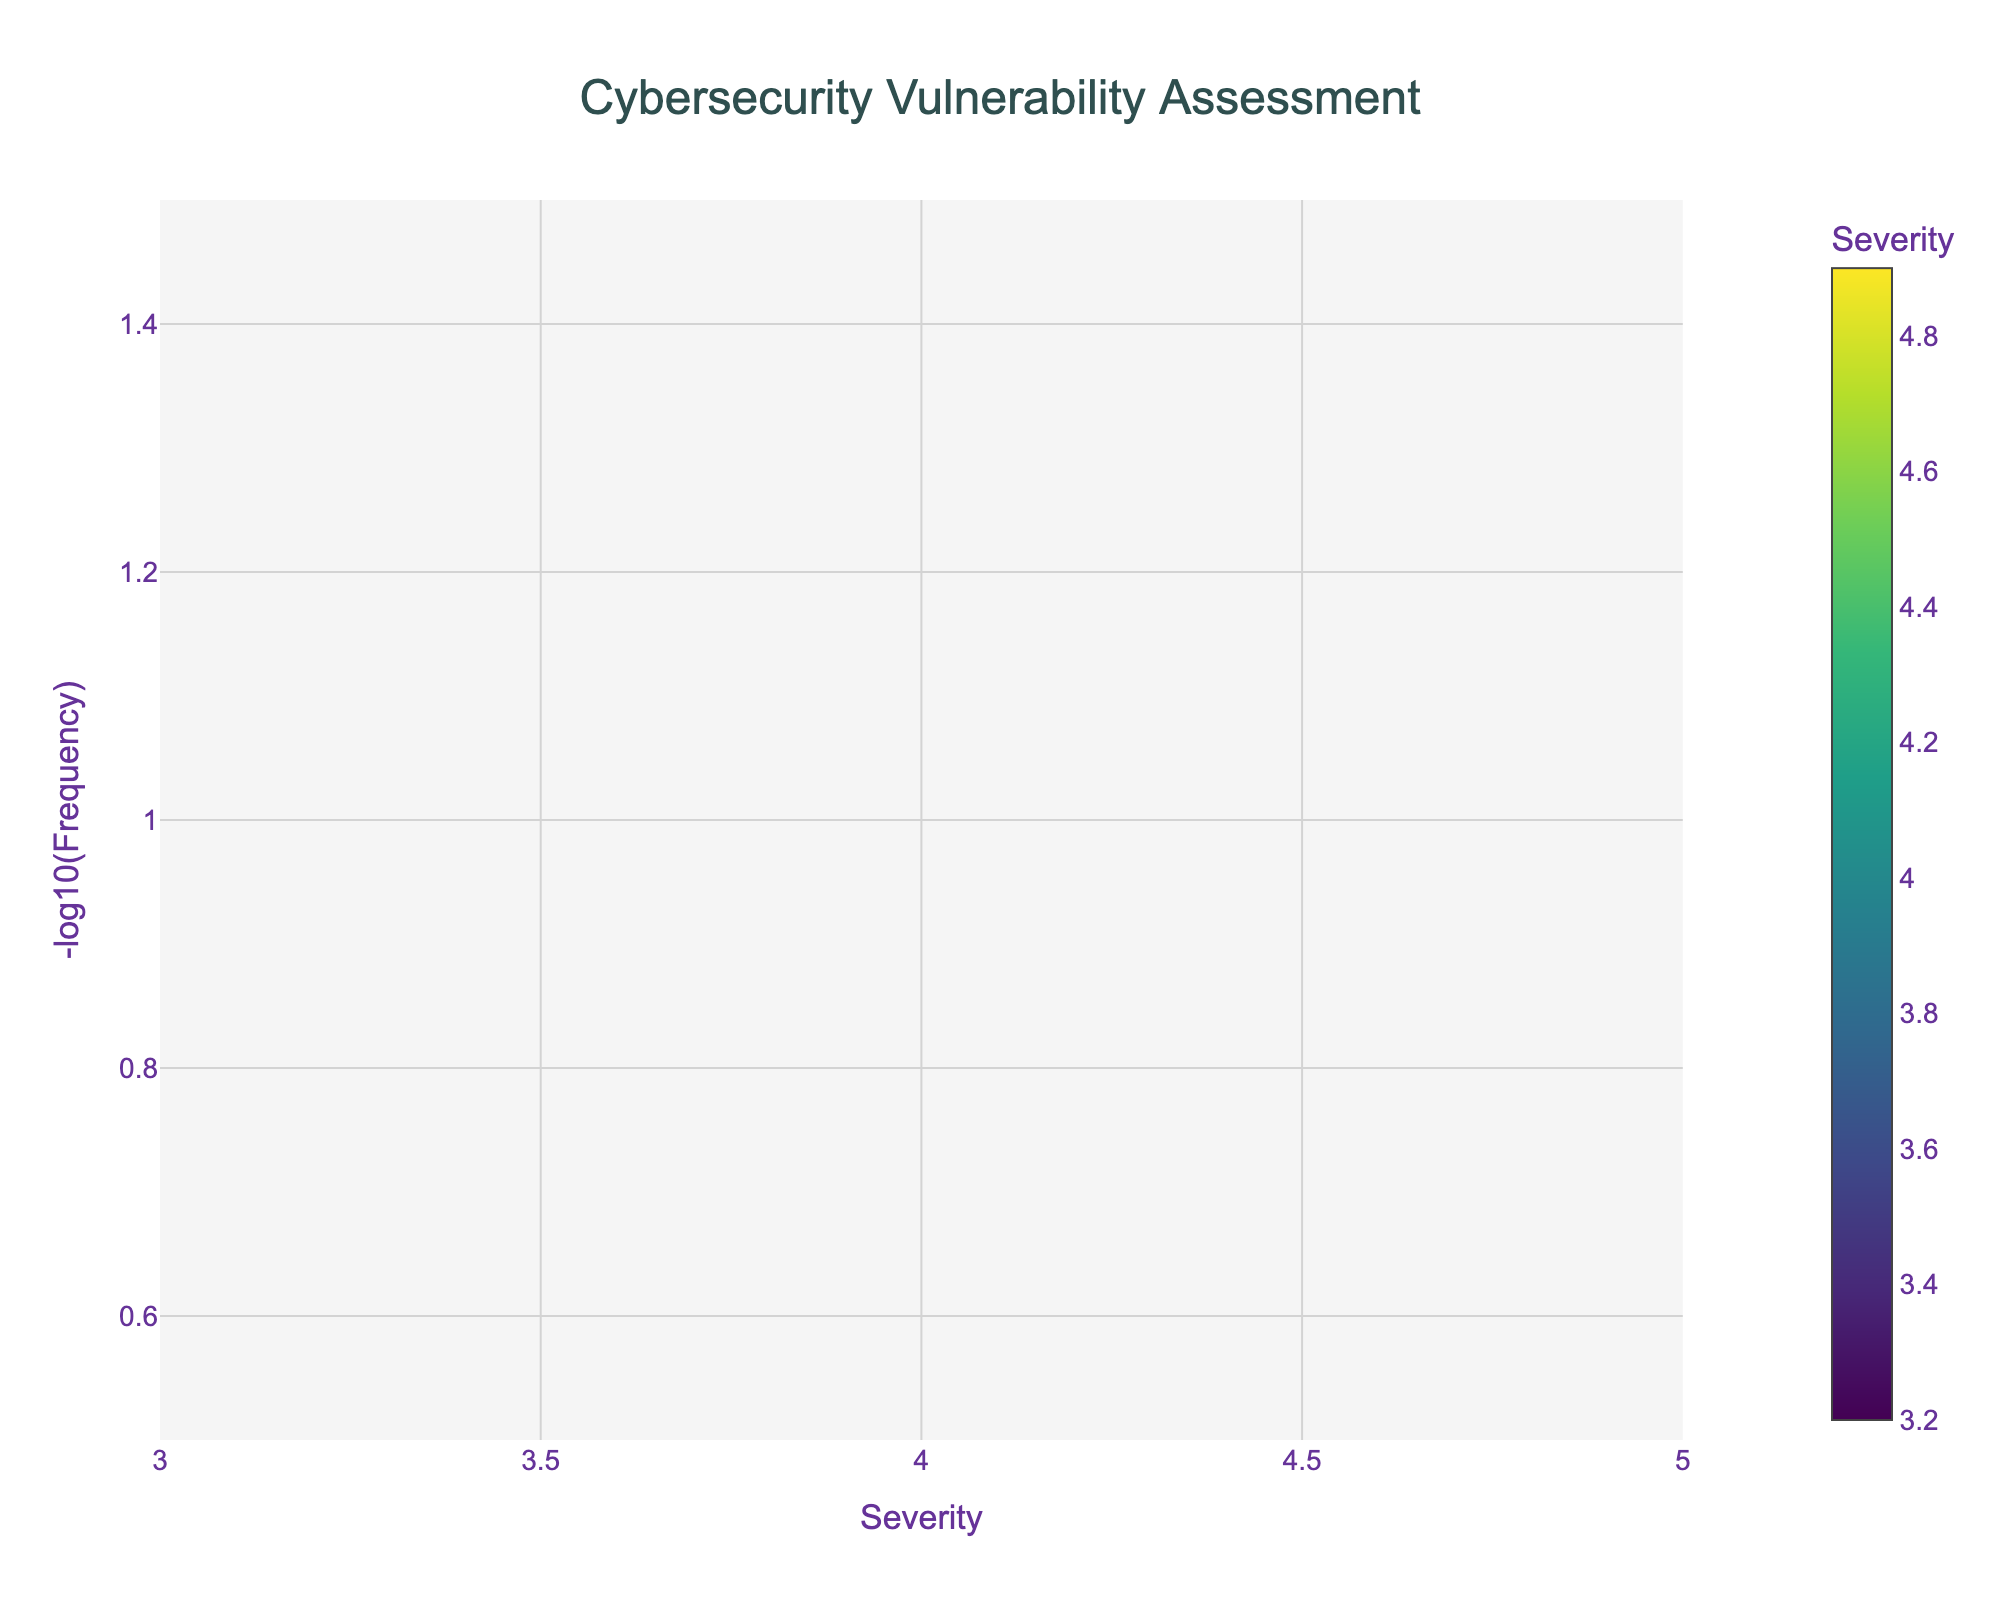What's the title of the figure? The title is usually located at the top of the figure. Here, the title is displayed centrally and given in large, bold font.
Answer: Cybersecurity Vulnerability Assessment How many unique vulnerabilities were assessed in the figure? Each dot in the volcano plot represents a unique vulnerability, and their names are visible next to the dots. By counting the dots, we can see there are 15 unique vulnerabilities.
Answer: 15 Which vulnerability has the highest severity? To find the highest severity, look for the dot that is farthest to the right on the x-axis (severity axis). The hover text for Privilege Escalation shows a severity of 4.9, the highest on the plot.
Answer: Privilege Escalation What is the frequency of the "SQL Injection" vulnerability? The frequency can be derived from the hover text associated with the dot labeled as "SQL Injection". The hover text specifies a frequency of 12.
Answer: 12 Which vulnerability occurs the most frequently? To find the most frequent vulnerability, look for the smallest value on the y-axis because the y-axis is -log10(Frequency). Information Disclosure has the smallest y-value and the highest y-position, indicating the most frequency at 25 incidents.
Answer: Information Disclosure Which vulnerabilities have a severity greater than 4.0 and a frequency lower than 10? To answer this, identify dots on the plot that lie to the right of 4.0 on the x-axis and higher (on the -log10 scale) than -log10(10), which is approximately 1.0. The vulnerabilities that satisfy these conditions are Privilege Escalation, Remote Code Execution, Man-in-the-Middle Attack, and Buffer Overflow.
Answer: Privilege Escalation, Remote Code Execution, Man-in-the-Middle Attack, Buffer Overflow What is the median severity value among the vulnerabilities plotted? To find the median severity, list all severity values (3.2, 3.4, 3.5, 3.6, 3.7, 3.8, 3.9, 4.1, 4.2, 4.3, 4.5, 4.6, 4.7, 4.8, 4.9) in ascending order. The median value, which is the middle value, is the 8th number in this list (3.2 to 4.9).
Answer: 3.9 Compare the severity of "Buffer Overflow" and "Cross-Site Request Forgery (CSRF)". Which one is higher? Locate both vulnerabilities on the figure. "Buffer Overflow" has a severity of 4.5 and "Cross-Site Request Forgery (CSRF)" has 3.4 as indicated by their positions on the x-axis. 4.5 is greater than 3.4.
Answer: Buffer Overflow What's the range of -log10(Frequency) values in the figure? Analyze the y-axis of the plot which ranges from approximately 0.6 (for Frequency 25) to 1.1 (for Frequency 12) as given by the positions of the dots.
Answer: 0.6 to 1.1 Which vulnerability has similar severity to "Denial of Service (DoS)" but a lower frequency? "Denial of Service (DoS)" has a severity of 4.1. Compare other vulnerabilities with similar severities but use the y-axis (-log10(Frequency)) to check for lower frequency. "SQL Injection" matches the severity of 4.2 (close to 4.1) and has a lower frequency of 12.
Answer: SQL Injection 